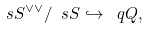<formula> <loc_0><loc_0><loc_500><loc_500>\ s S ^ { \vee \vee } / \ s S \hookrightarrow \ q Q ,</formula> 